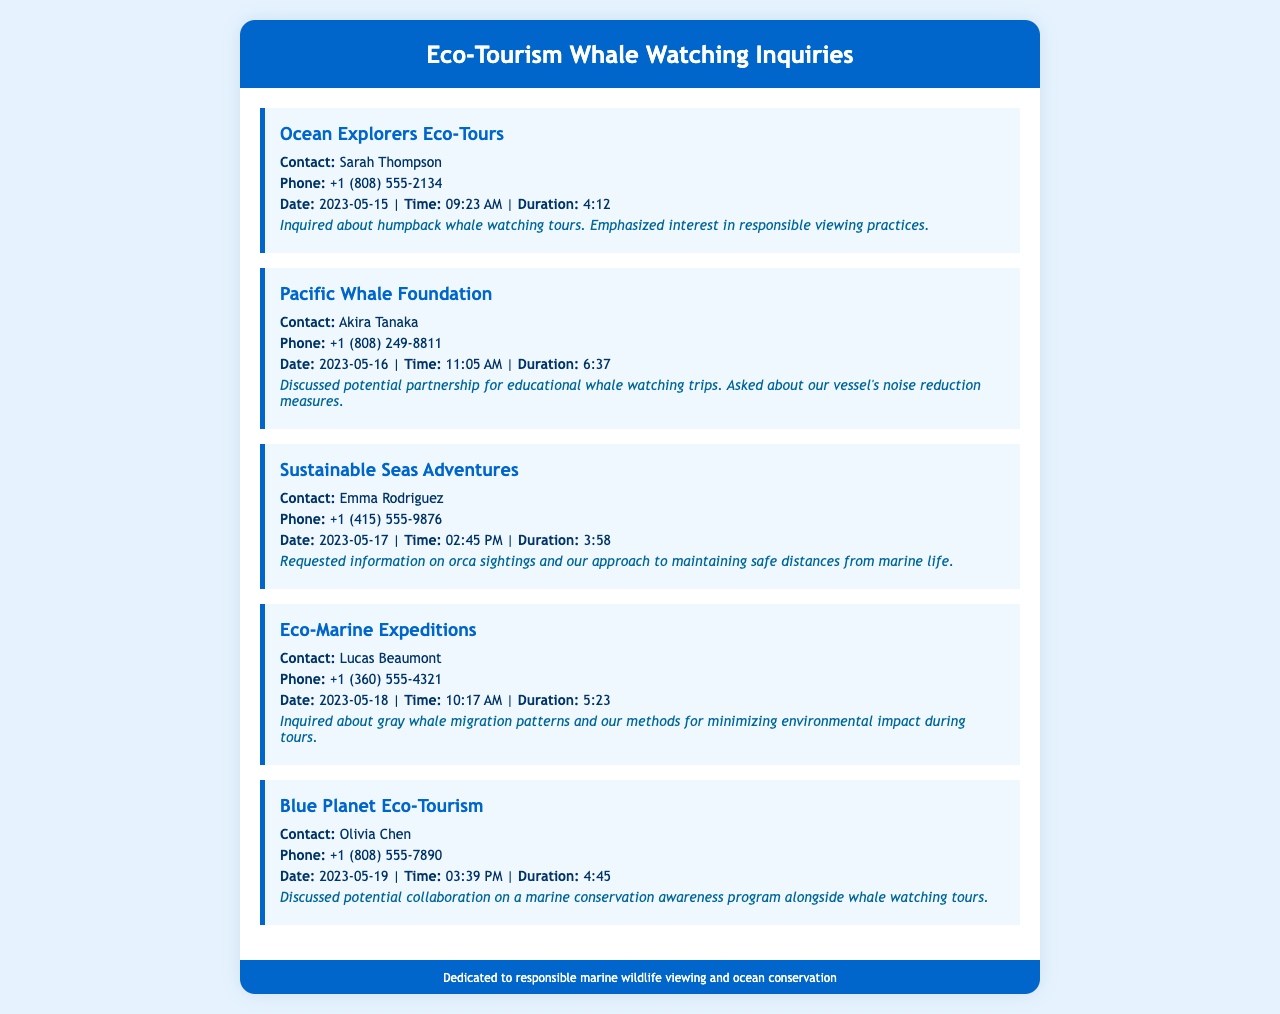What is the name of the first agency that called? The first agency listed in the document is Ocean Explorers Eco-Tours.
Answer: Ocean Explorers Eco-Tours Who was the contact person for the Pacific Whale Foundation? The contact person mentioned for the Pacific Whale Foundation is Akira Tanaka.
Answer: Akira Tanaka What date did Sustainable Seas Adventures inquire? The inquiry by Sustainable Seas Adventures was made on May 17, 2023.
Answer: 2023-05-17 How long was the call from Eco-Marine Expeditions? The duration of the call from Eco-Marine Expeditions was 5 minutes and 23 seconds.
Answer: 5:23 Which organization asked about gray whale migration patterns? Eco-Marine Expeditions inquired about gray whale migration patterns.
Answer: Eco-Marine Expeditions What common interest was discussed by Blue Planet Eco-Tourism? Blue Planet Eco-Tourism discussed a marine conservation awareness program.
Answer: marine conservation awareness program How many agencies inquired about responsible viewing practices? Two agencies showed interest in responsible viewing practices (Ocean Explorers Eco-Tours and Sustainable Seas Adventures).
Answer: Two What was Emma Rodriguez's role? Emma Rodriguez is the contact for Sustainable Seas Adventures.
Answer: contact Which agency discussed vessel noise reduction measures? The Pacific Whale Foundation discussed vessel noise reduction measures.
Answer: Pacific Whale Foundation 